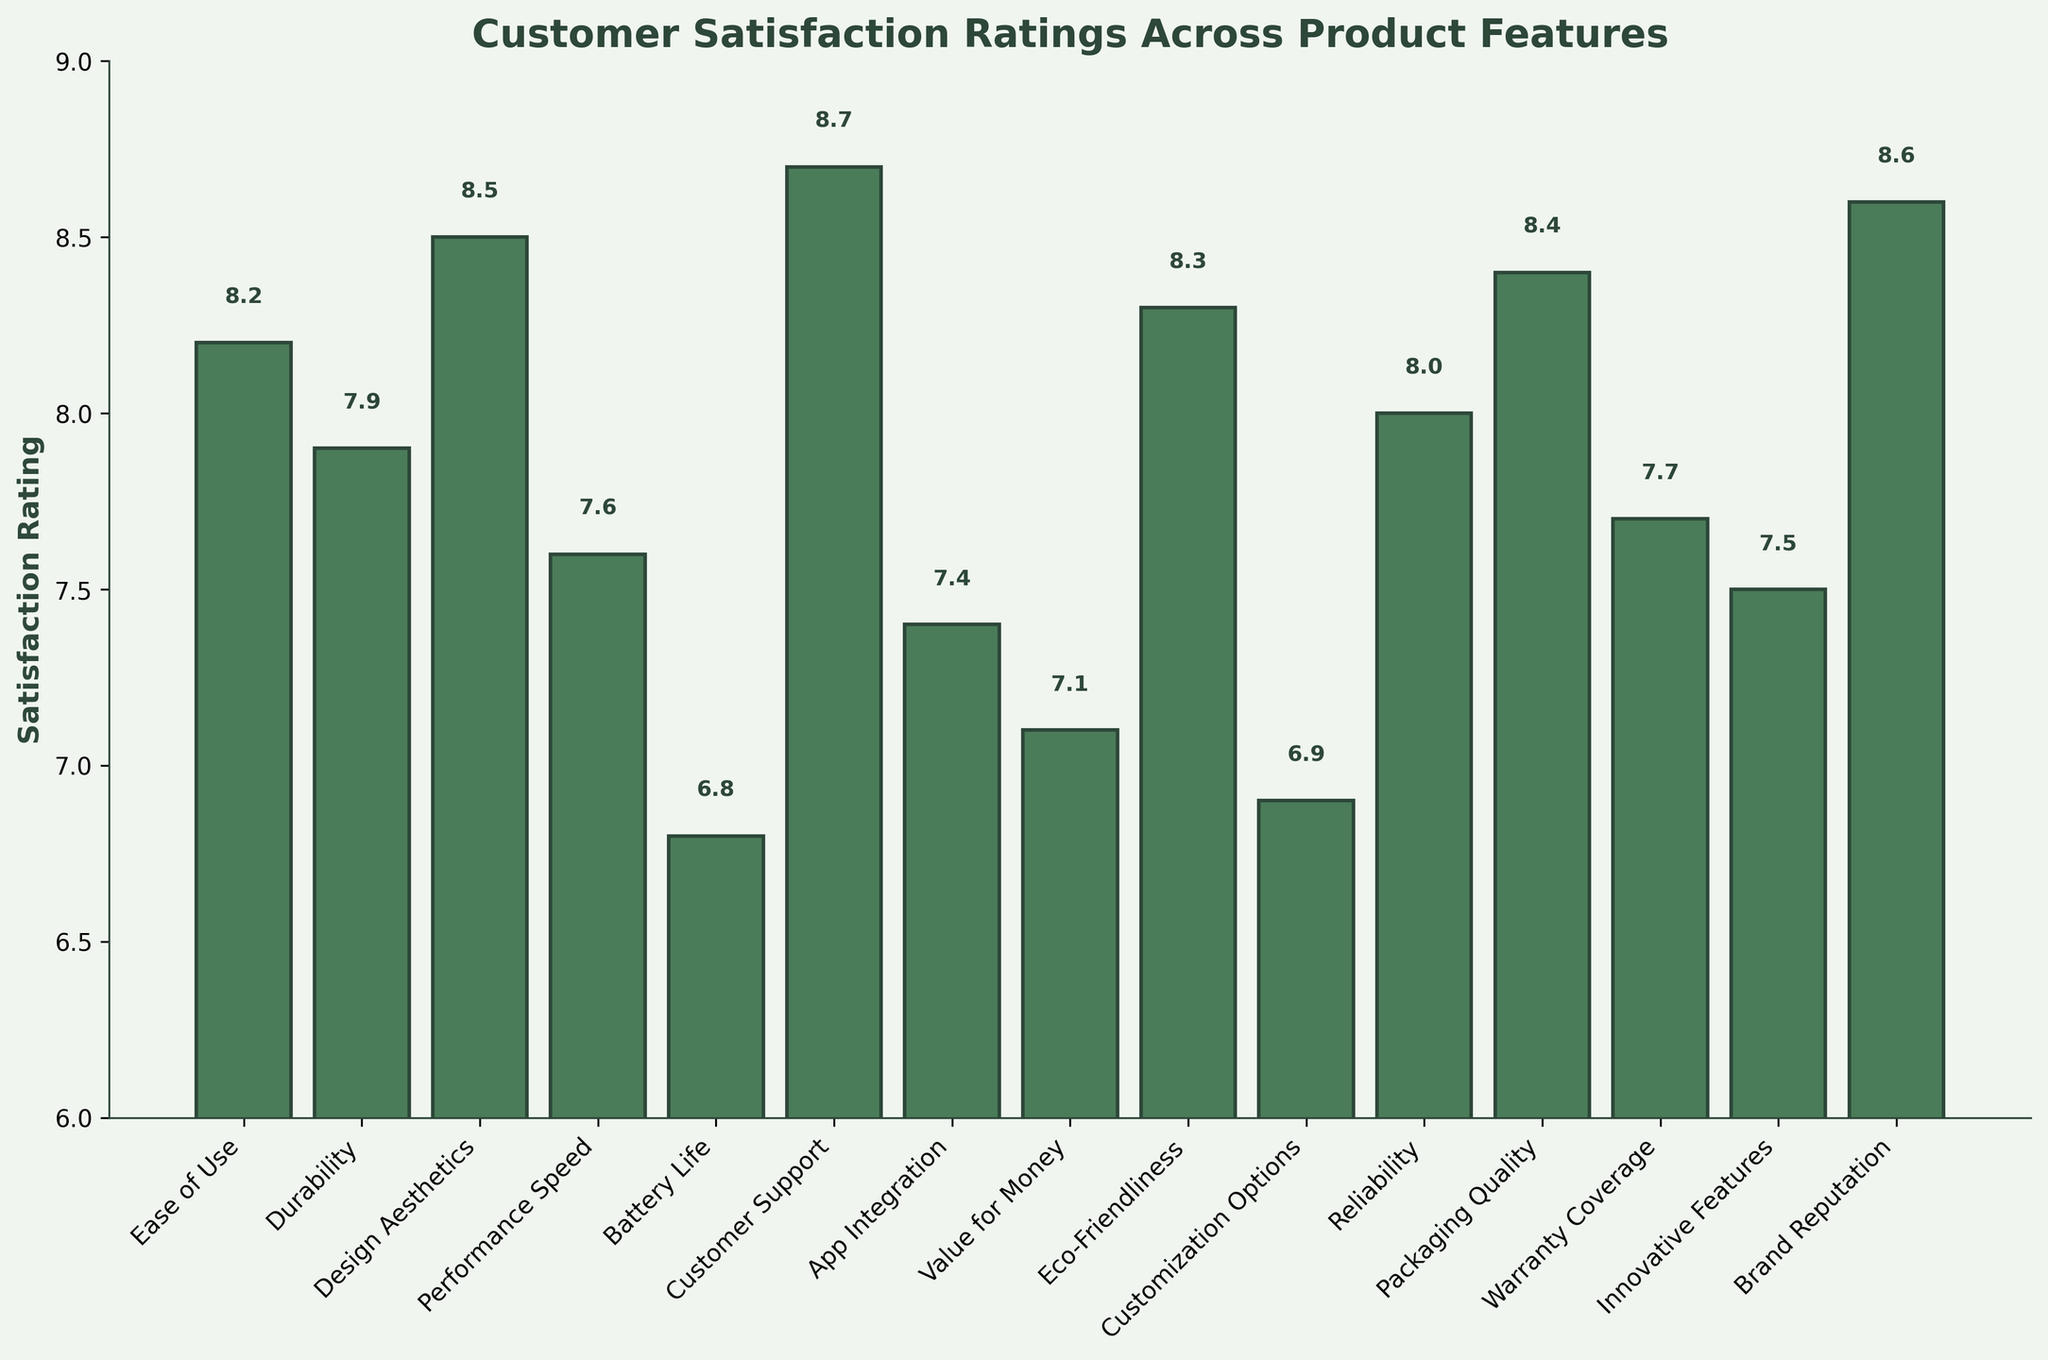What is the highest customer satisfaction rating, and for which product feature? The chart shows various bars, each representing a product feature's satisfaction rating. The highest rating corresponds to the tallest bar, labeled "Customer Support" with a rating of 8.7.
Answer: Customer Support - 8.7 Which product feature has the lowest satisfaction rating? By observing the shortest bar in the chart, the feature "Battery Life" has the lowest satisfaction rating of 6.8.
Answer: Battery Life - 6.8 How does the satisfaction rating for "Ease of Use" compare to "Design Aesthetics"? The rating for "Ease of Use" is 8.2, while "Design Aesthetics" is 8.5. Comparing these values, "Design Aesthetics" is higher by 0.3 points.
Answer: Design Aesthetics is higher by 0.3 What is the difference in satisfaction ratings between "Value for Money" and "Warranty Coverage"? "Value for Money" has a rating of 7.1, and "Warranty Coverage" has 7.7. Subtracting these values yields a difference of 0.6.
Answer: 0.6 What is the average customer satisfaction rating of the product features? The sum of all satisfaction ratings is 111.2, and there are 15 product features. Dividing the total rating by the number of features gives an average rating of 7.41.
Answer: 7.41 How does "Brand Reputation" compare to the average customer satisfaction rating? "Brand Reputation" has a rating of 8.6. The average satisfaction rating is 7.41. Comparing these, "Brand Reputation" is higher by 1.19.
Answer: Brand Reputation is higher by 1.19 Which three features have ratings above 8.0? The features with ratings above 8.0 are identified by their bar heights: "Customer Support" (8.7), "Brand Reputation" (8.6), and "Design Aesthetics" (8.5).
Answer: Customer Support, Brand Reputation, Design Aesthetics What is the median rating of all product features? To find the median, the ratings are sorted in ascending order: 6.8, 6.9, 7.1, 7.4, 7.5, 7.6, 7.7, 7.9, 8.0, 8.2, 8.3, 8.4, 8.5, 8.6, 8.7. With 15 features, the median is the 8th value: 7.9.
Answer: 7.9 How does the satisfaction rating of "Battery Life" compare with "Eco-Friendliness"? "Battery Life" has a satisfaction rating of 6.8, whereas "Eco-Friendliness" has 8.3. "Eco-Friendliness" is higher by 1.5.
Answer: Eco-Friendliness is higher by 1.5 What range of ratings do the features cover? The range is calculated by subtracting the lowest rating (6.8 for "Battery Life") from the highest rating (8.7 for "Customer Support"), resulting in a range of 1.9.
Answer: 1.9 